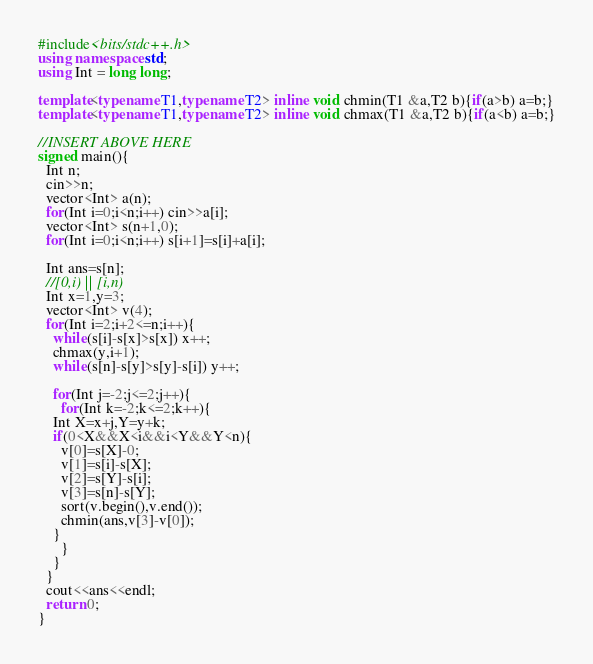<code> <loc_0><loc_0><loc_500><loc_500><_C++_>#include<bits/stdc++.h>
using namespace std;
using Int = long long;

template<typename T1,typename T2> inline void chmin(T1 &a,T2 b){if(a>b) a=b;}
template<typename T1,typename T2> inline void chmax(T1 &a,T2 b){if(a<b) a=b;}

//INSERT ABOVE HERE
signed main(){
  Int n;
  cin>>n;
  vector<Int> a(n);
  for(Int i=0;i<n;i++) cin>>a[i];
  vector<Int> s(n+1,0);
  for(Int i=0;i<n;i++) s[i+1]=s[i]+a[i];

  Int ans=s[n];
  //[0,i) || [i,n)
  Int x=1,y=3;
  vector<Int> v(4);
  for(Int i=2;i+2<=n;i++){
    while(s[i]-s[x]>s[x]) x++;
    chmax(y,i+1);
    while(s[n]-s[y]>s[y]-s[i]) y++;
    
    for(Int j=-2;j<=2;j++){
      for(Int k=-2;k<=2;k++){
	Int X=x+j,Y=y+k;
	if(0<X&&X<i&&i<Y&&Y<n){
	  v[0]=s[X]-0;
	  v[1]=s[i]-s[X];
	  v[2]=s[Y]-s[i];
	  v[3]=s[n]-s[Y];
	  sort(v.begin(),v.end());
	  chmin(ans,v[3]-v[0]);
	}
      }
    }
  }
  cout<<ans<<endl;
  return 0;
}
</code> 